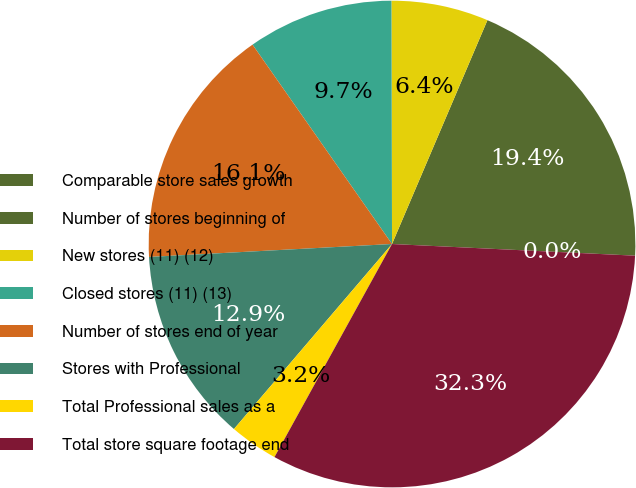Convert chart. <chart><loc_0><loc_0><loc_500><loc_500><pie_chart><fcel>Comparable store sales growth<fcel>Number of stores beginning of<fcel>New stores (11) (12)<fcel>Closed stores (11) (13)<fcel>Number of stores end of year<fcel>Stores with Professional<fcel>Total Professional sales as a<fcel>Total store square footage end<nl><fcel>0.0%<fcel>19.35%<fcel>6.45%<fcel>9.68%<fcel>16.13%<fcel>12.9%<fcel>3.23%<fcel>32.26%<nl></chart> 